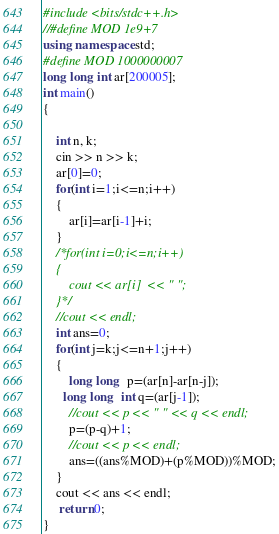<code> <loc_0><loc_0><loc_500><loc_500><_C++_>#include <bits/stdc++.h>
//#define MOD 1e9+7
using namespace std;
#define MOD 1000000007
long long int ar[200005];
int main()
{

    int n, k;
    cin >> n >> k;
    ar[0]=0;
    for(int i=1;i<=n;i++)
    {
        ar[i]=ar[i-1]+i;
    }
    /*for(int i=0;i<=n;i++)
    {
        cout << ar[i]  << " ";
    }*/
    //cout << endl;
    int ans=0;
    for(int j=k;j<=n+1;j++)
    {
        long long  p=(ar[n]-ar[n-j]);
      long long  int q=(ar[j-1]);
        //cout << p << " " << q << endl;
        p=(p-q)+1;
        //cout << p << endl;
        ans=((ans%MOD)+(p%MOD))%MOD;
    }
    cout << ans << endl;
     return 0;
}
</code> 